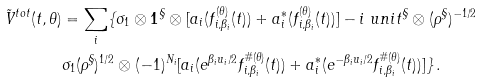<formula> <loc_0><loc_0><loc_500><loc_500>\tilde { V } ^ { t o t } ( t , \theta ) & = \sum _ { i } \{ \sigma _ { 1 } \otimes { \mathbf 1 } ^ { \S } \otimes [ a _ { i } ( f _ { i , \beta _ { i } } ^ { ( \theta ) } ( t ) ) + a _ { i } ^ { * } ( f _ { i , \beta _ { i } } ^ { ( \theta ) } ( t ) ) ] - i \ u n i t ^ { \S } \otimes ( \rho ^ { \S } ) ^ { - 1 / 2 } \\ & \sigma _ { 1 } ( \rho ^ { \S } ) ^ { 1 / 2 } \otimes ( - 1 ) ^ { N _ { i } } [ a _ { i } ( e ^ { \beta _ { i } u _ { i } / 2 } f _ { i , \beta _ { i } } ^ { \# ( \theta ) } ( t ) ) + a _ { i } ^ { * } ( e ^ { - \beta _ { i } u _ { i } / 2 } f _ { i , \beta _ { i } } ^ { \# ( \theta ) } ( t ) ) ] \} \, .</formula> 